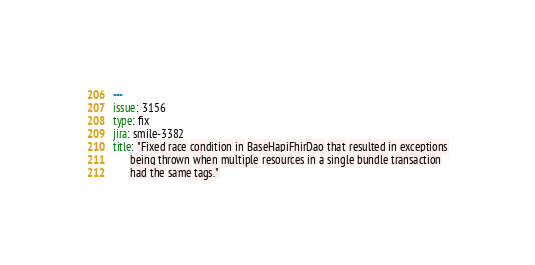Convert code to text. <code><loc_0><loc_0><loc_500><loc_500><_YAML_>---
issue: 3156
type: fix
jira: smile-3382
title: "Fixed race condition in BaseHapiFhirDao that resulted in exceptions
      being thrown when multiple resources in a single bundle transaction
      had the same tags."
</code> 